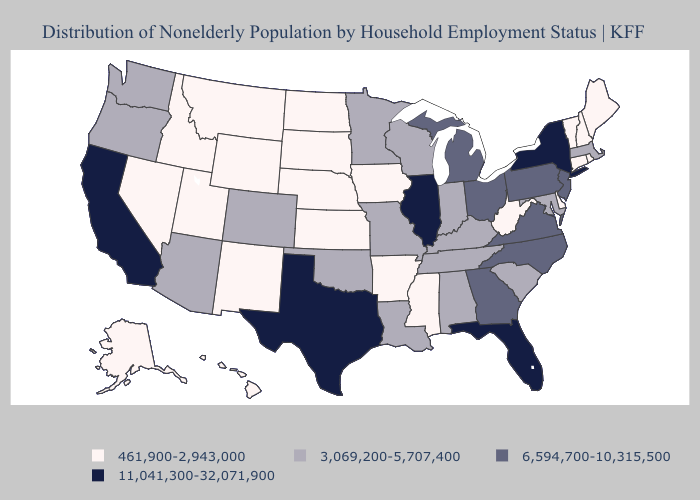Does West Virginia have the lowest value in the USA?
Keep it brief. Yes. Does North Dakota have the highest value in the USA?
Be succinct. No. Among the states that border Alabama , does Florida have the highest value?
Answer briefly. Yes. How many symbols are there in the legend?
Short answer required. 4. Among the states that border Indiana , which have the lowest value?
Short answer required. Kentucky. What is the value of Rhode Island?
Short answer required. 461,900-2,943,000. Which states have the lowest value in the South?
Be succinct. Arkansas, Delaware, Mississippi, West Virginia. What is the value of Colorado?
Quick response, please. 3,069,200-5,707,400. Name the states that have a value in the range 11,041,300-32,071,900?
Quick response, please. California, Florida, Illinois, New York, Texas. What is the value of Maine?
Answer briefly. 461,900-2,943,000. What is the value of Idaho?
Keep it brief. 461,900-2,943,000. What is the value of Delaware?
Give a very brief answer. 461,900-2,943,000. What is the value of Georgia?
Be succinct. 6,594,700-10,315,500. Which states have the lowest value in the USA?
Write a very short answer. Alaska, Arkansas, Connecticut, Delaware, Hawaii, Idaho, Iowa, Kansas, Maine, Mississippi, Montana, Nebraska, Nevada, New Hampshire, New Mexico, North Dakota, Rhode Island, South Dakota, Utah, Vermont, West Virginia, Wyoming. What is the highest value in states that border Alabama?
Be succinct. 11,041,300-32,071,900. 